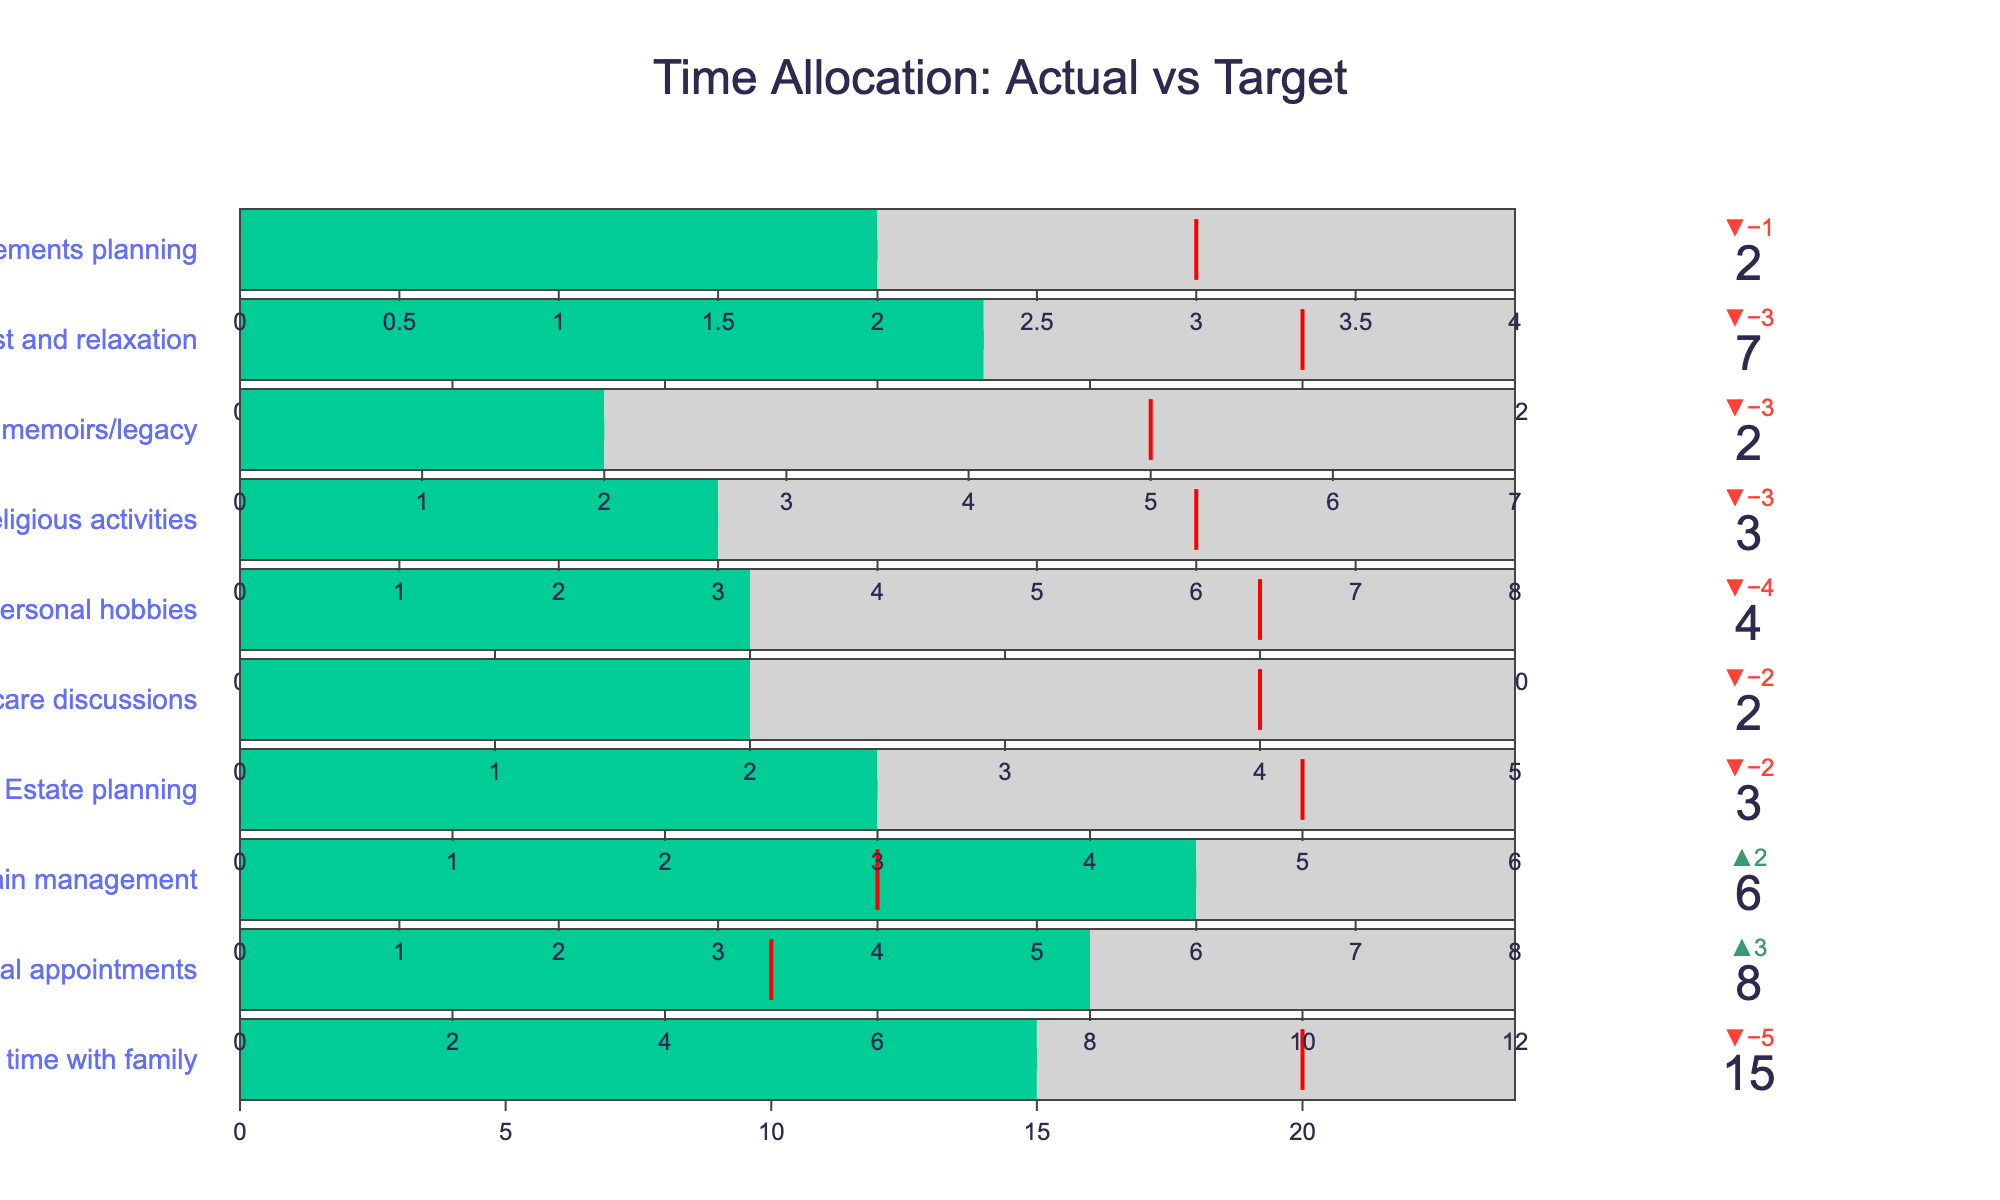what is the time spent on personal hobbies compared to the target time? To find the time spent on personal hobbies and compare it to the target time, look at the category "Personal hobbies": the actual time spent is 4 hours, and the target time is 8 hours. The difference is 8 - 4 = 4.
Answer: 4 hours less what is the title of the chart? The title of the chart is usually the largest text at the top of the figure. Here, it is "Time Allocation: Actual vs Target."
Answer: Time Allocation: Actual vs Target Which category has the largest difference between actual and target time? To find the category with the largest difference, look for the biggest delta indicated by the gap between actual and target times. "Writing memoirs/legacy" has an actual time of 2 hours and a target of 5 hours, yielding a difference of 5 - 2 = 3 hours.
Answer: Writing memoirs/legacy What is the target time for medical appointments compared to the actual time spent? For the category "Medical appointments," the actual time spent is 8 hours. The target time is 5 hours. The difference is 8 - 5 = 3 hours.
Answer: 3 hours more By how much time are you surpassing the recommended rest and relaxation? For "Rest and relaxation," the actual time spent is 7 hours, and the target time is 10 hours. Since 7 is less than 10, you are actually not surpassing but falling short by 10 - 7 = 3 hours.
Answer: 3 hours less How many categories are there in total? Count the number of unique categories listed on the y-axis. There are 10 categories, each representing a different activity.
Answer: 10 What color represents the time spent on "Spiritual/religious activities"? The color for the actual time spent in each category is consistent. In this chart, the actual time is represented in green (#00CC96), so the same applies to "Spiritual/religious activities."
Answer: Green What's the average of the target times for "Estate planning", "Writing memoirs/legacy," and "Final arrangements planning"? Add up the target times for the three categories and divide by the number of categories. The targets are 5, 5, and 3, respectively. (5 + 5 + 3) / 3 = 13/3 ≈ 4.33 hours.
Answer: 4.33 hours Which category is closest to meeting its target time allocation? Look for the category where the difference between actual and target times is minimal. "Final arrangements planning" has an actual time of 2 hours and a target of 3 hours, a difference of 1 hour.
Answer: Final arrangements planning 